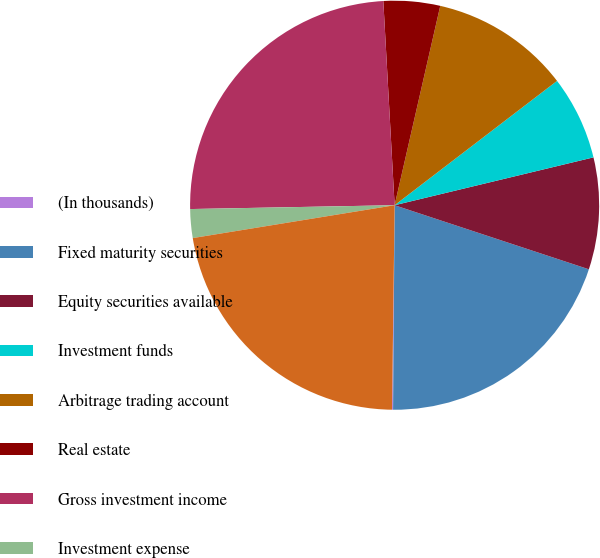<chart> <loc_0><loc_0><loc_500><loc_500><pie_chart><fcel>(In thousands)<fcel>Fixed maturity securities<fcel>Equity securities available<fcel>Investment funds<fcel>Arbitrage trading account<fcel>Real estate<fcel>Gross investment income<fcel>Investment expense<fcel>Net investment income<nl><fcel>0.08%<fcel>20.05%<fcel>8.83%<fcel>6.64%<fcel>11.02%<fcel>4.46%<fcel>24.42%<fcel>2.27%<fcel>22.23%<nl></chart> 